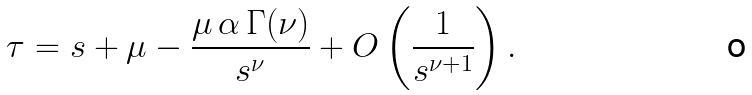<formula> <loc_0><loc_0><loc_500><loc_500>\tau = s + \mu - \frac { \mu \, \alpha \, \Gamma ( \nu ) } { s ^ { \nu } } + O \left ( \frac { 1 } { s ^ { \nu + 1 } } \right ) .</formula> 